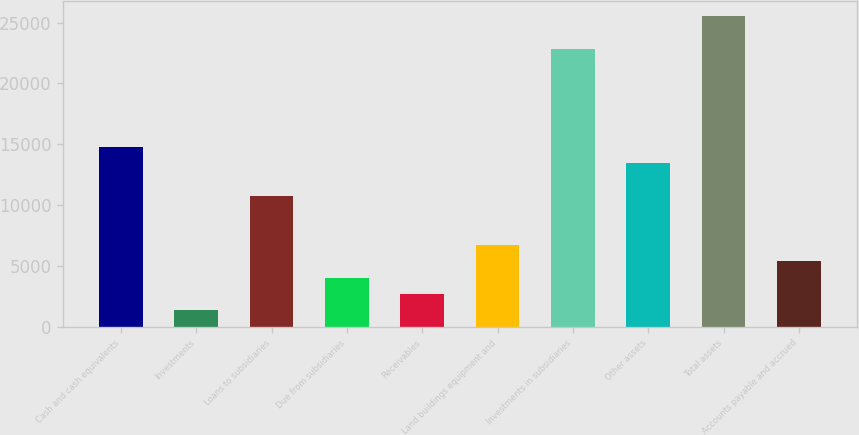Convert chart. <chart><loc_0><loc_0><loc_500><loc_500><bar_chart><fcel>Cash and cash equivalents<fcel>Investments<fcel>Loans to subsidiaries<fcel>Due from subsidiaries<fcel>Receivables<fcel>Land buildings equipment and<fcel>Investments in subsidiaries<fcel>Other assets<fcel>Total assets<fcel>Accounts payable and accrued<nl><fcel>14774.9<fcel>1345.9<fcel>10746.2<fcel>4031.7<fcel>2688.8<fcel>6717.5<fcel>22832.3<fcel>13432<fcel>25518.1<fcel>5374.6<nl></chart> 